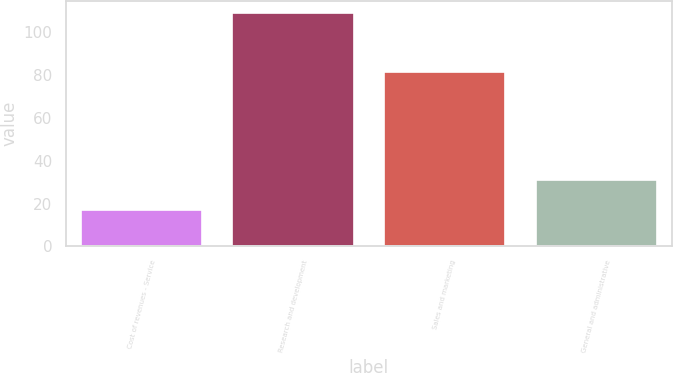<chart> <loc_0><loc_0><loc_500><loc_500><bar_chart><fcel>Cost of revenues - Service<fcel>Research and development<fcel>Sales and marketing<fcel>General and administrative<nl><fcel>17<fcel>109.1<fcel>81.6<fcel>31.1<nl></chart> 